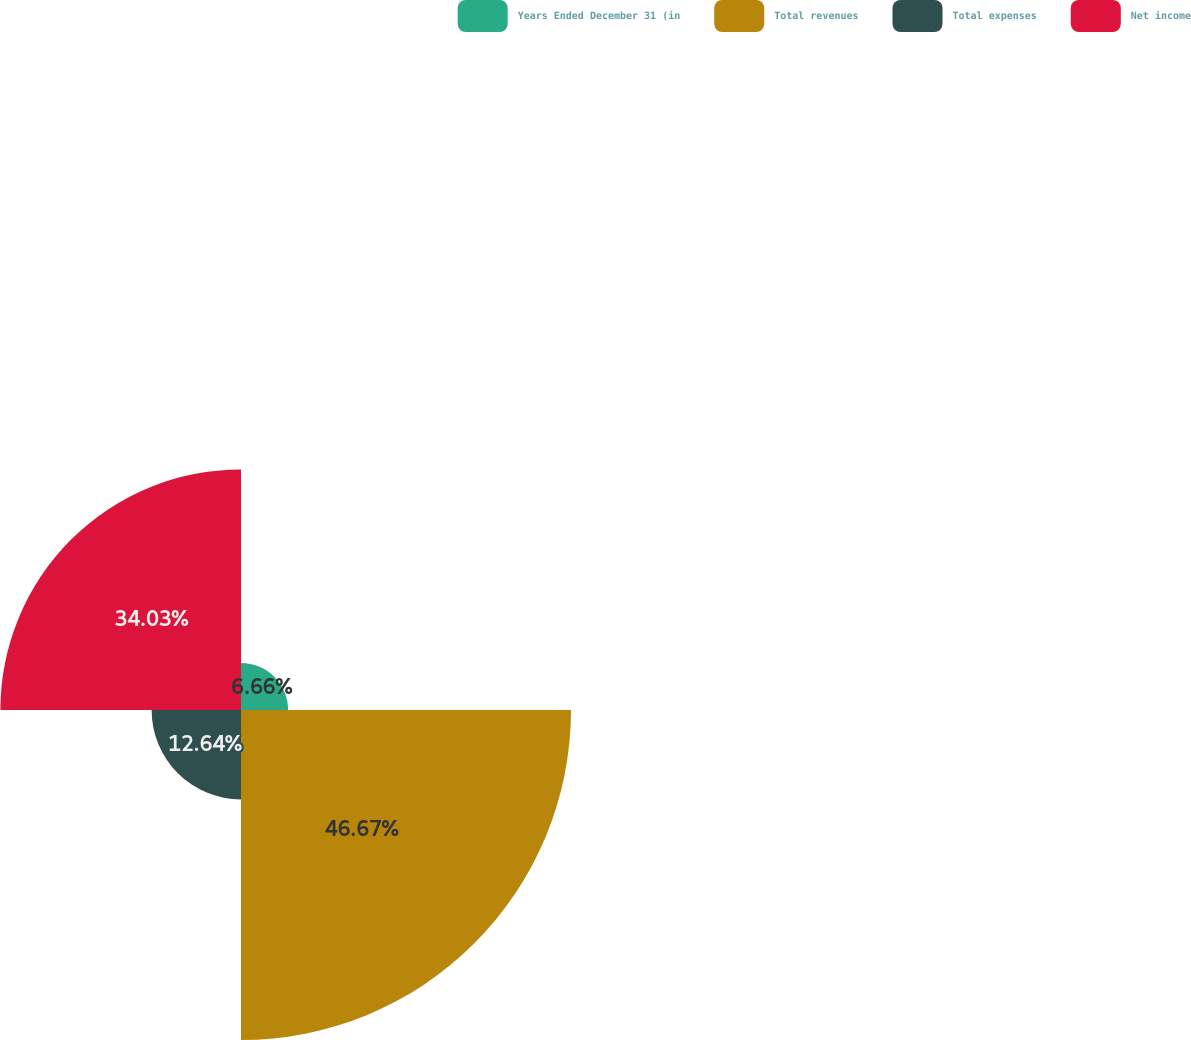Convert chart. <chart><loc_0><loc_0><loc_500><loc_500><pie_chart><fcel>Years Ended December 31 (in<fcel>Total revenues<fcel>Total expenses<fcel>Net income<nl><fcel>6.66%<fcel>46.67%<fcel>12.64%<fcel>34.03%<nl></chart> 